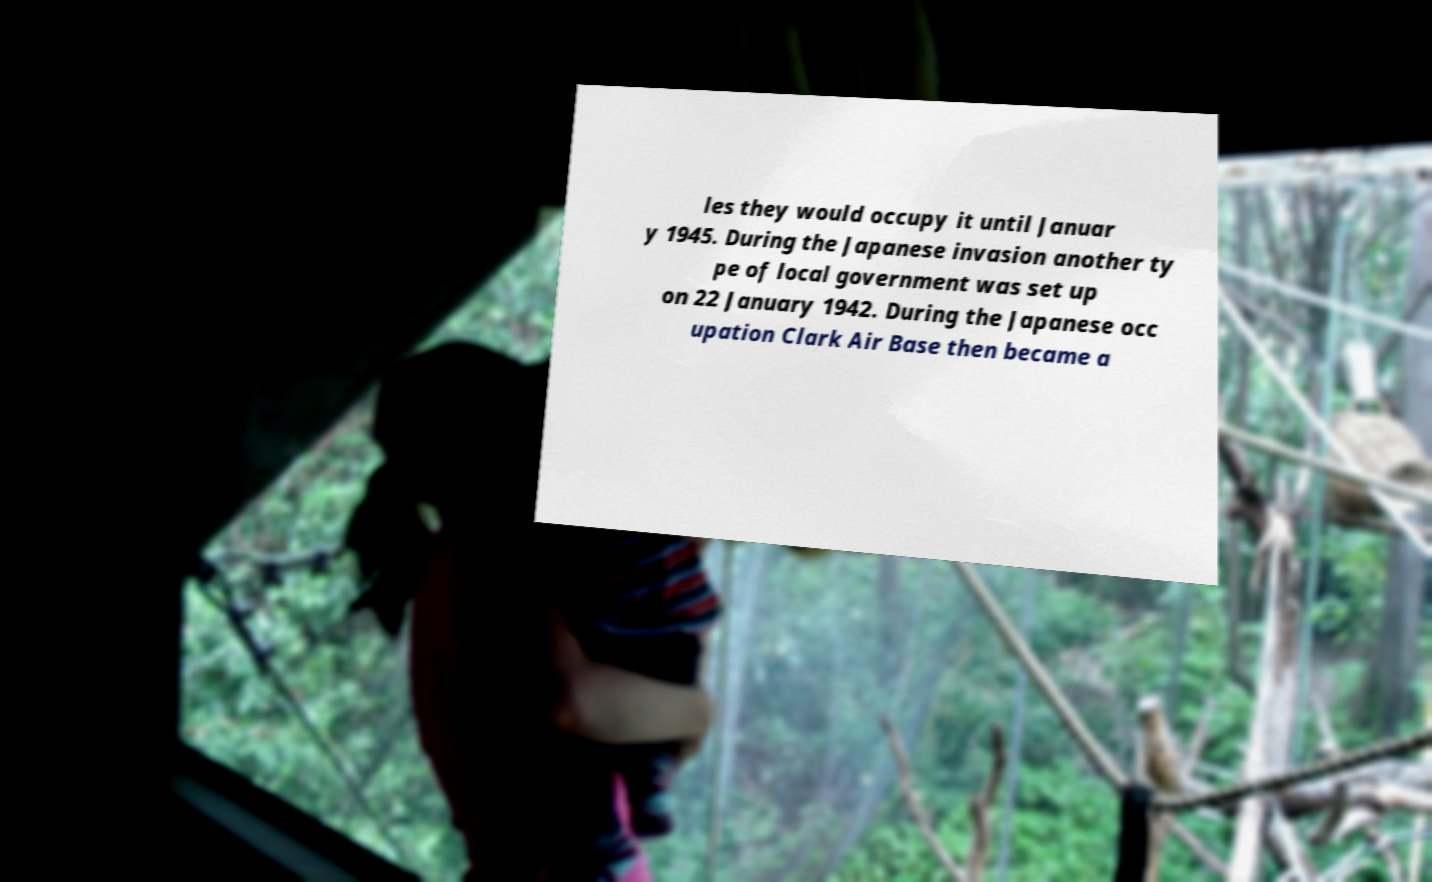I need the written content from this picture converted into text. Can you do that? les they would occupy it until Januar y 1945. During the Japanese invasion another ty pe of local government was set up on 22 January 1942. During the Japanese occ upation Clark Air Base then became a 